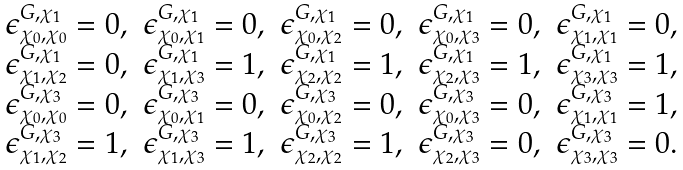Convert formula to latex. <formula><loc_0><loc_0><loc_500><loc_500>\begin{array} { l l l l l } \epsilon ^ { G , \chi _ { 1 } } _ { \chi _ { 0 } , \chi _ { 0 } } = 0 , & \epsilon ^ { G , \chi _ { 1 } } _ { \chi _ { 0 } , \chi _ { 1 } } = 0 , & \epsilon ^ { G , \chi _ { 1 } } _ { \chi _ { 0 } , \chi _ { 2 } } = 0 , & \epsilon ^ { G , \chi _ { 1 } } _ { \chi _ { 0 } , \chi _ { 3 } } = 0 , & \epsilon ^ { G , \chi _ { 1 } } _ { \chi _ { 1 } , \chi _ { 1 } } = 0 , \\ \epsilon ^ { G , \chi _ { 1 } } _ { \chi _ { 1 } , \chi _ { 2 } } = 0 , & \epsilon ^ { G , \chi _ { 1 } } _ { \chi _ { 1 } , \chi _ { 3 } } = 1 , & \epsilon ^ { G , \chi _ { 1 } } _ { \chi _ { 2 } , \chi _ { 2 } } = 1 , & \epsilon ^ { G , \chi _ { 1 } } _ { \chi _ { 2 } , \chi _ { 3 } } = 1 , & \epsilon ^ { G , \chi _ { 1 } } _ { \chi _ { 3 } , \chi _ { 3 } } = 1 , \\ \epsilon ^ { G , \chi _ { 3 } } _ { \chi _ { 0 } , \chi _ { 0 } } = 0 , & \epsilon ^ { G , \chi _ { 3 } } _ { \chi _ { 0 } , \chi _ { 1 } } = 0 , & \epsilon ^ { G , \chi _ { 3 } } _ { \chi _ { 0 } , \chi _ { 2 } } = 0 , & \epsilon ^ { G , \chi _ { 3 } } _ { \chi _ { 0 } , \chi _ { 3 } } = 0 , & \epsilon ^ { G , \chi _ { 3 } } _ { \chi _ { 1 } , \chi _ { 1 } } = 1 , \\ \epsilon ^ { G , \chi _ { 3 } } _ { \chi _ { 1 } , \chi _ { 2 } } = 1 , & \epsilon ^ { G , \chi _ { 3 } } _ { \chi _ { 1 } , \chi _ { 3 } } = 1 , & \epsilon ^ { G , \chi _ { 3 } } _ { \chi _ { 2 } , \chi _ { 2 } } = 1 , & \epsilon ^ { G , \chi _ { 3 } } _ { \chi _ { 2 } , \chi _ { 3 } } = 0 , & \epsilon ^ { G , \chi _ { 3 } } _ { \chi _ { 3 } , \chi _ { 3 } } = 0 . \end{array}</formula> 